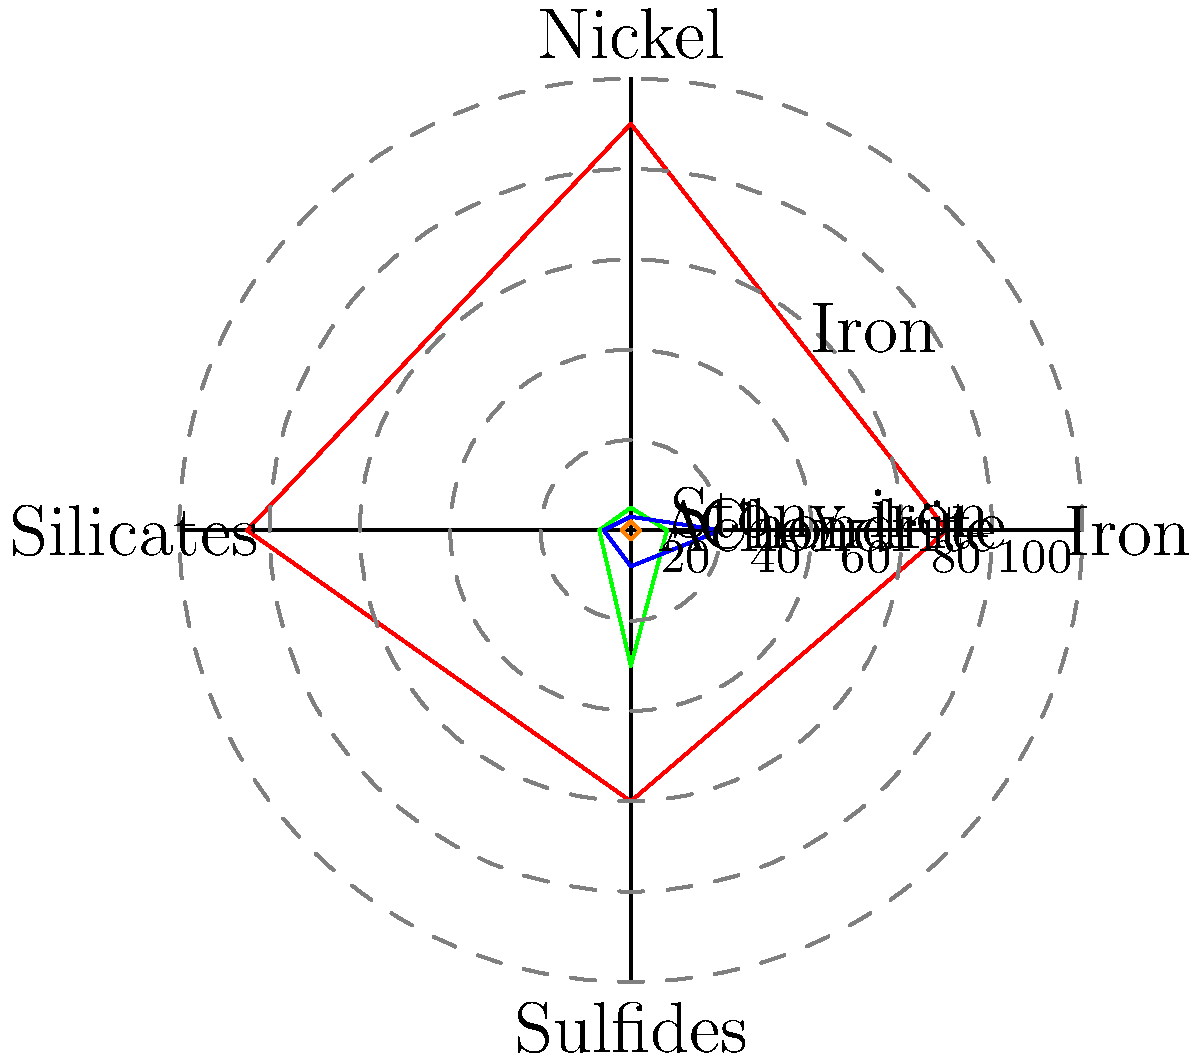Based on the radar chart showing the elemental composition of four different types of meteorites, which type has the highest percentage of nickel and how does its iron content compare to the other types? To answer this question, we need to analyze the radar chart carefully:

1. The chart shows four types of meteorites: Iron, Stony-iron, Chondrite, and Achondrite.
2. Each axis represents a different element: Iron, Nickel, Silicates, and Sulfides.
3. The percentage of each element is shown by the distance from the center along each axis.

Let's examine the nickel content first:
a) Iron meteorite: ~8%
b) Stony-iron meteorite: ~5%
c) Chondrite: ~7%
d) Achondrite: ~30%

The Achondrite meteorite clearly has the highest percentage of nickel at about 30%.

Now, let's compare the iron content of the Achondrite to the other types:
a) Iron meteorite: ~70%
b) Stony-iron meteorite: ~90%
c) Chondrite: ~85%
d) Achondrite: ~60%

The Achondrite has the lowest iron content among all four types, at approximately 60%.

Therefore, the Achondrite meteorite has the highest nickel content while having the lowest iron content compared to the other meteorite types.
Answer: Achondrite; lowest iron content 